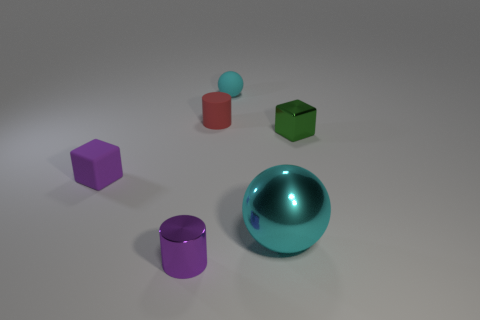Add 1 purple cylinders. How many objects exist? 7 Subtract all spheres. How many objects are left? 4 Add 2 purple rubber blocks. How many purple rubber blocks exist? 3 Subtract 1 purple cubes. How many objects are left? 5 Subtract all yellow rubber cylinders. Subtract all purple metallic cylinders. How many objects are left? 5 Add 3 things. How many things are left? 9 